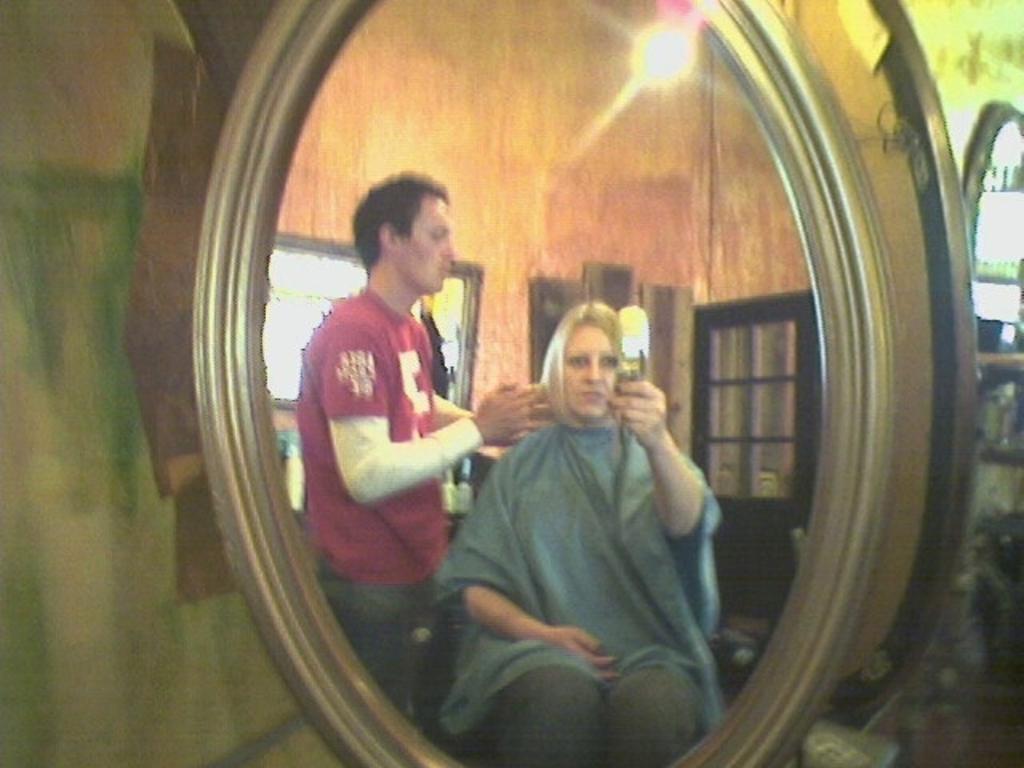In one or two sentences, can you explain what this image depicts? In the picture I can see the mirror in which I can see the reflection of a woman holding a camera and sitting and I can see a man wearing red color T-shirt is standing. In the background, I can see windows and lights. 